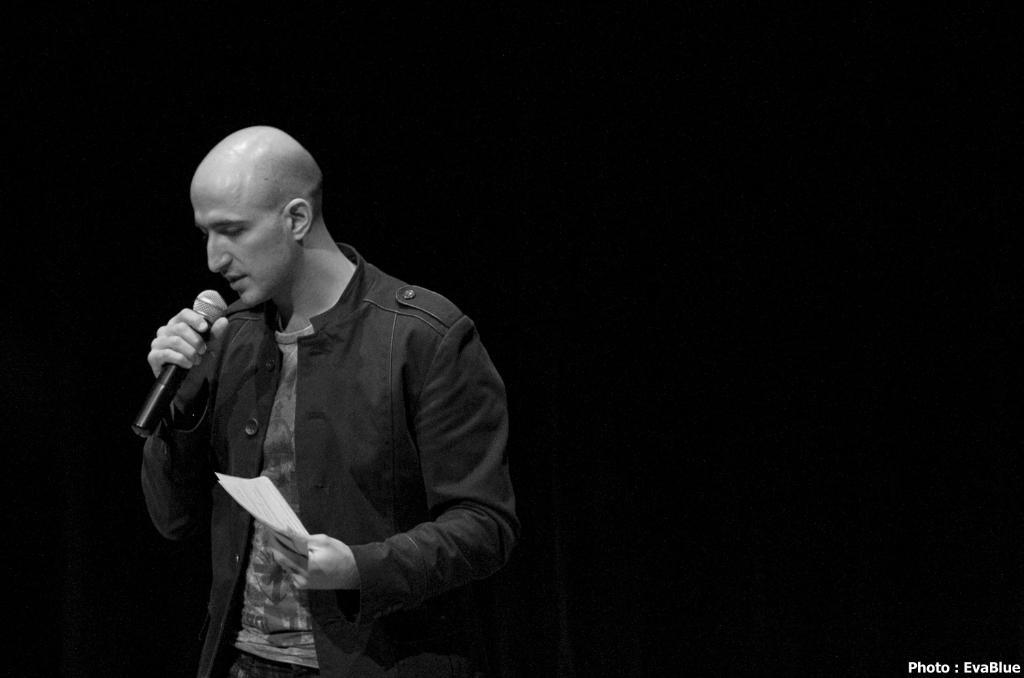What is the main subject of the image? There is a man in the image. What is the man doing in the image? The man is standing and singing a song. What is the man holding in one hand? The man is holding a microphone in one hand. What is the man holding in the other hand? The man is holding a paper in the other hand. What type of clothing is the man wearing? The man is wearing a jerkin. What is the color scheme of the image? The image is black and white. What type of calendar is hanging on the wall behind the man in the image? There is no calendar present in the image. What is the man eating for lunch in the image? There is no lunch depicted in the image; the man is singing and holding a microphone and paper. 